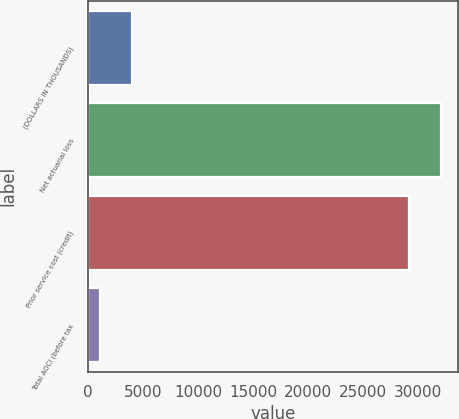Convert chart. <chart><loc_0><loc_0><loc_500><loc_500><bar_chart><fcel>(DOLLARS IN THOUSANDS)<fcel>Net actuarial loss<fcel>Prior service cost (credit)<fcel>Total AOCI (before tax<nl><fcel>3973.9<fcel>32074.9<fcel>29159<fcel>1058<nl></chart> 